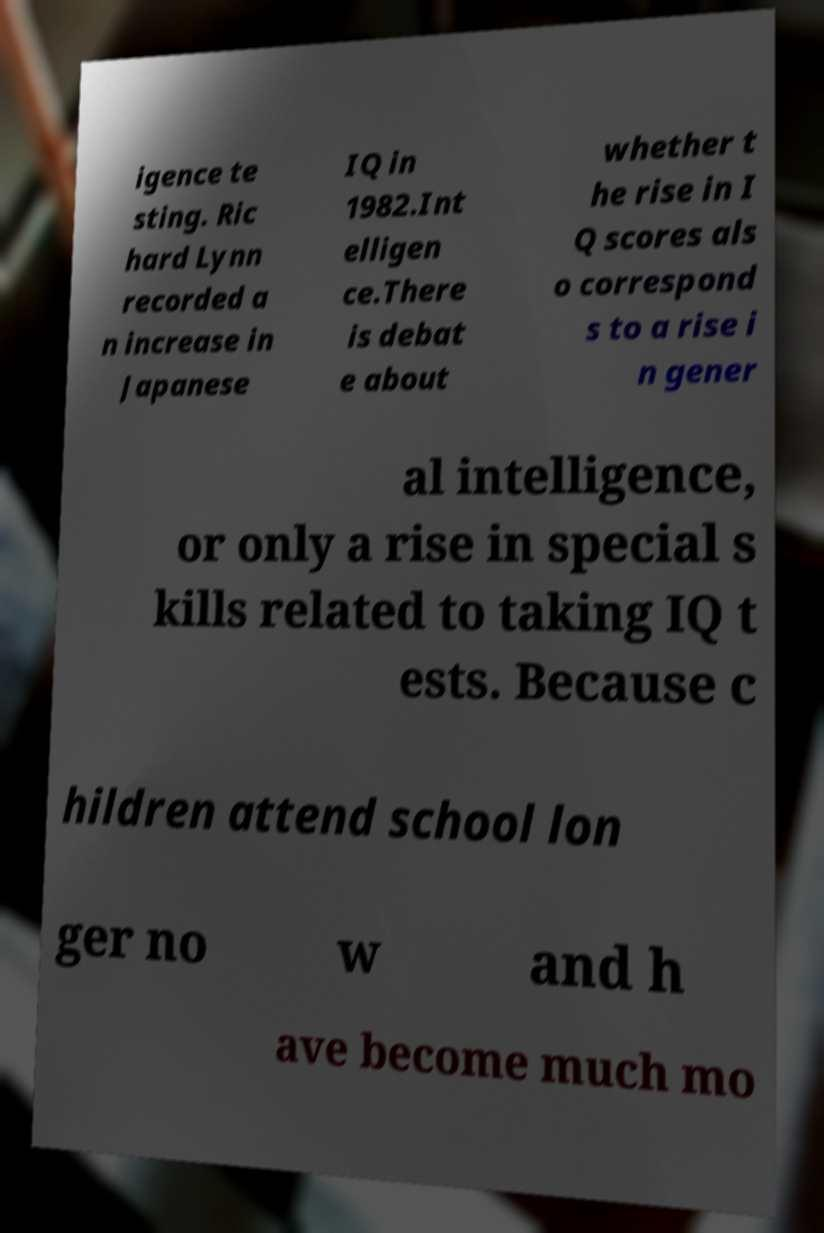Can you accurately transcribe the text from the provided image for me? igence te sting. Ric hard Lynn recorded a n increase in Japanese IQ in 1982.Int elligen ce.There is debat e about whether t he rise in I Q scores als o correspond s to a rise i n gener al intelligence, or only a rise in special s kills related to taking IQ t ests. Because c hildren attend school lon ger no w and h ave become much mo 